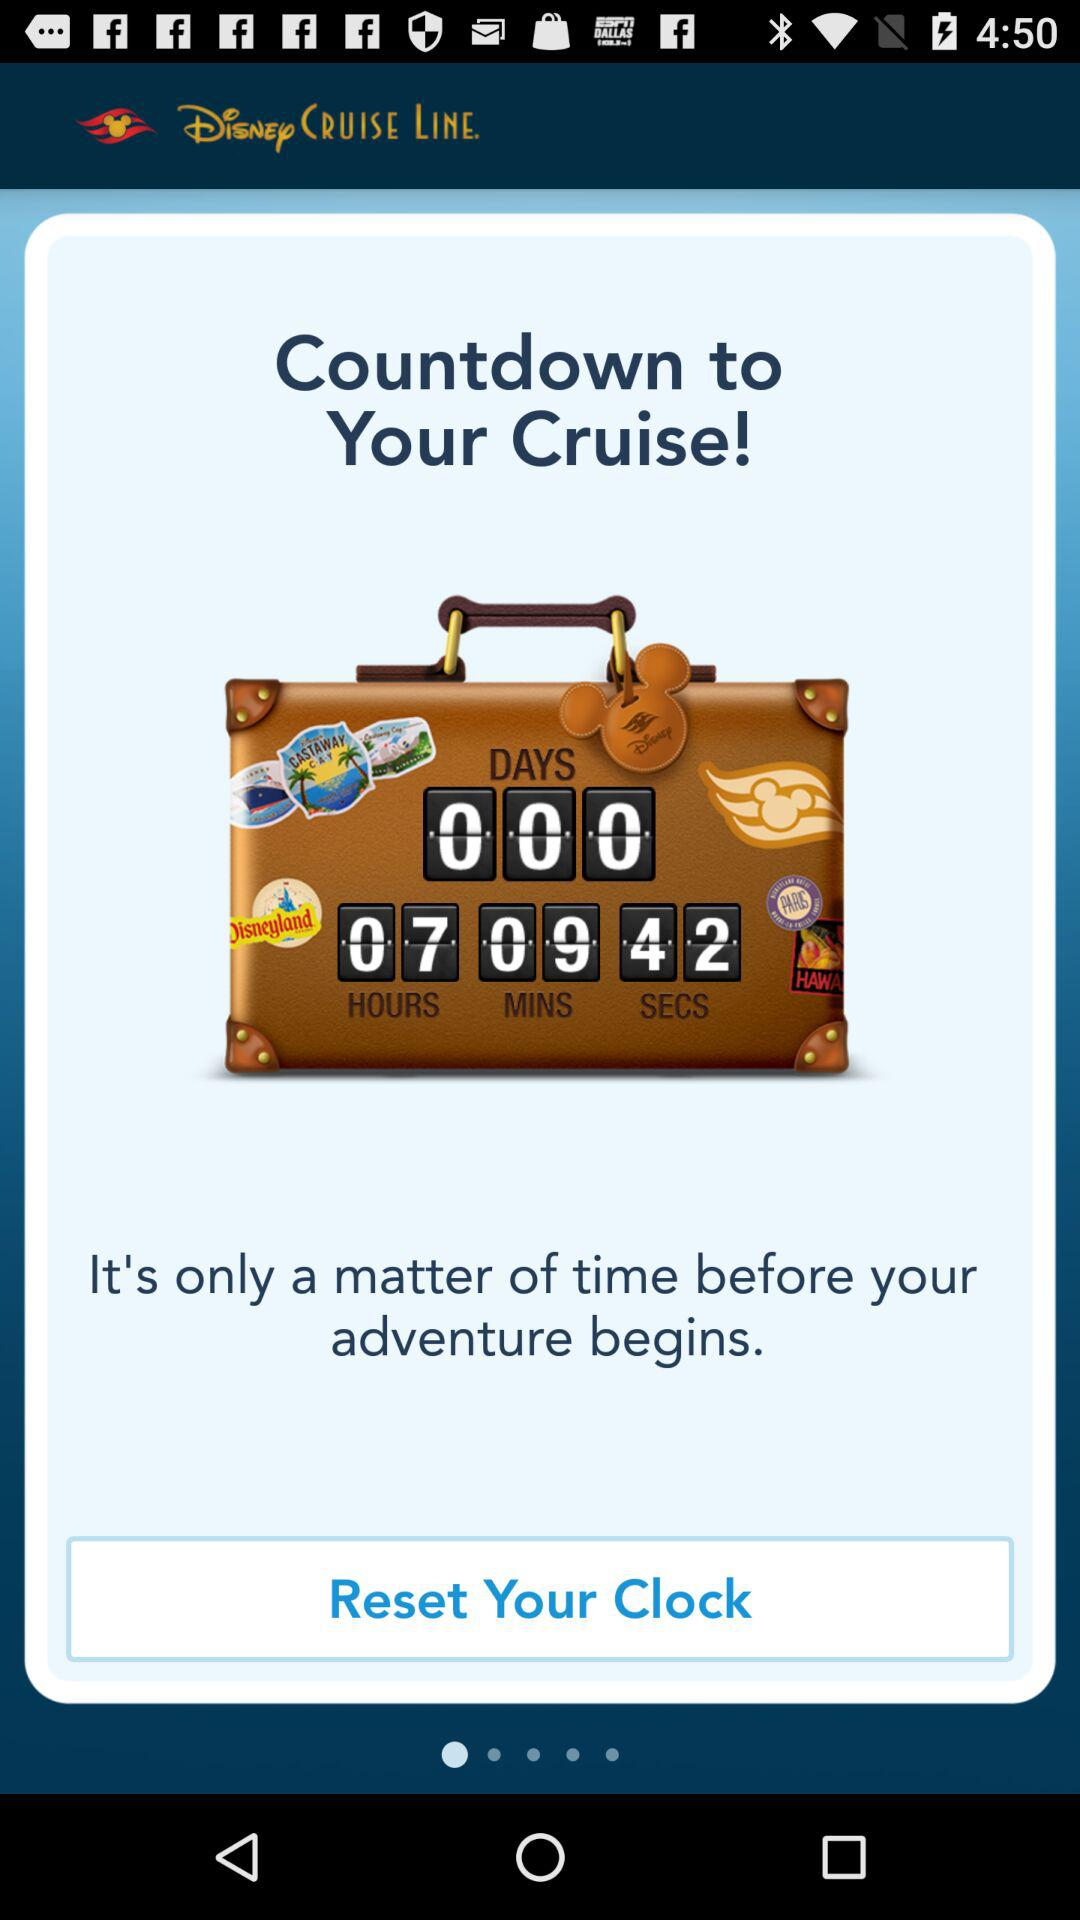How many minutes are left for the countdown to your cruise? There are 9 minutes left for the countdown to your cruise. 